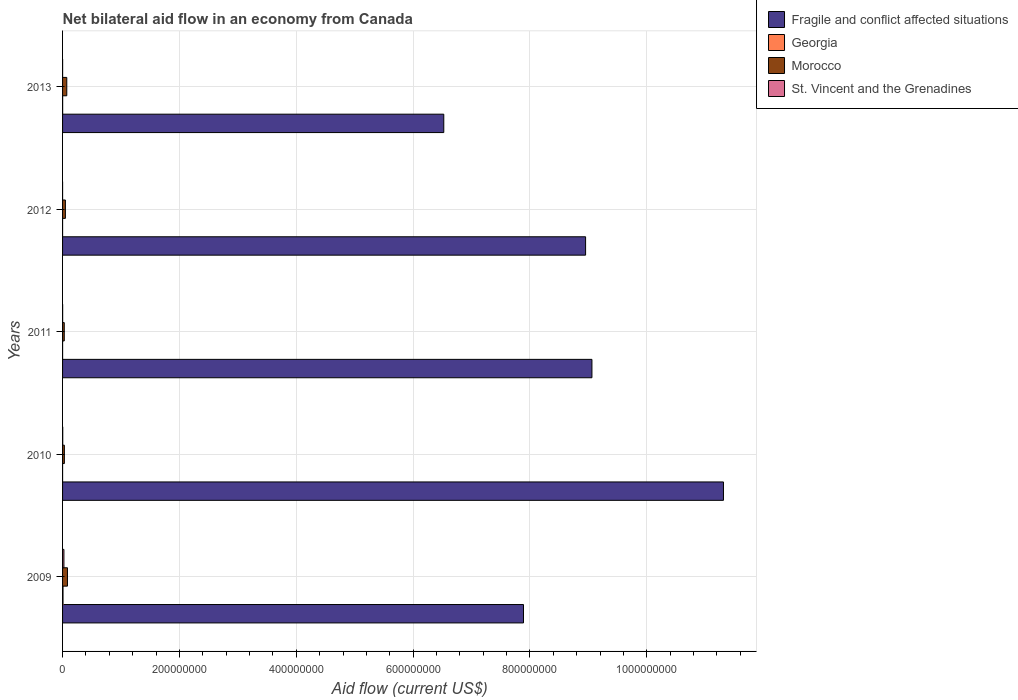How many groups of bars are there?
Provide a succinct answer. 5. Are the number of bars per tick equal to the number of legend labels?
Provide a short and direct response. Yes. Are the number of bars on each tick of the Y-axis equal?
Offer a terse response. Yes. How many bars are there on the 1st tick from the top?
Your answer should be very brief. 4. What is the net bilateral aid flow in Georgia in 2009?
Your response must be concise. 7.70e+05. Across all years, what is the maximum net bilateral aid flow in Fragile and conflict affected situations?
Offer a terse response. 1.13e+09. Across all years, what is the minimum net bilateral aid flow in Fragile and conflict affected situations?
Your answer should be very brief. 6.52e+08. In which year was the net bilateral aid flow in Georgia minimum?
Keep it short and to the point. 2012. What is the total net bilateral aid flow in Georgia in the graph?
Your answer should be very brief. 1.01e+06. What is the difference between the net bilateral aid flow in Morocco in 2011 and that in 2013?
Ensure brevity in your answer.  -4.30e+06. What is the difference between the net bilateral aid flow in Georgia in 2013 and the net bilateral aid flow in Morocco in 2012?
Your answer should be very brief. -4.71e+06. What is the average net bilateral aid flow in St. Vincent and the Grenadines per year?
Offer a very short reply. 5.70e+05. In the year 2011, what is the difference between the net bilateral aid flow in Georgia and net bilateral aid flow in Morocco?
Keep it short and to the point. -2.85e+06. In how many years, is the net bilateral aid flow in Morocco greater than 520000000 US$?
Provide a short and direct response. 0. What is the ratio of the net bilateral aid flow in St. Vincent and the Grenadines in 2009 to that in 2013?
Offer a very short reply. 33.29. Is the net bilateral aid flow in Fragile and conflict affected situations in 2010 less than that in 2012?
Your answer should be compact. No. What is the difference between the highest and the second highest net bilateral aid flow in Morocco?
Offer a very short reply. 1.17e+06. What is the difference between the highest and the lowest net bilateral aid flow in St. Vincent and the Grenadines?
Provide a succinct answer. 2.30e+06. What does the 2nd bar from the top in 2013 represents?
Offer a terse response. Morocco. What does the 1st bar from the bottom in 2009 represents?
Keep it short and to the point. Fragile and conflict affected situations. How many years are there in the graph?
Make the answer very short. 5. What is the difference between two consecutive major ticks on the X-axis?
Offer a terse response. 2.00e+08. Does the graph contain grids?
Your answer should be compact. Yes. Where does the legend appear in the graph?
Offer a terse response. Top right. How are the legend labels stacked?
Keep it short and to the point. Vertical. What is the title of the graph?
Ensure brevity in your answer.  Net bilateral aid flow in an economy from Canada. Does "Luxembourg" appear as one of the legend labels in the graph?
Ensure brevity in your answer.  No. What is the label or title of the Y-axis?
Your answer should be compact. Years. What is the Aid flow (current US$) of Fragile and conflict affected situations in 2009?
Ensure brevity in your answer.  7.89e+08. What is the Aid flow (current US$) in Georgia in 2009?
Offer a terse response. 7.70e+05. What is the Aid flow (current US$) in Morocco in 2009?
Keep it short and to the point. 8.38e+06. What is the Aid flow (current US$) in St. Vincent and the Grenadines in 2009?
Keep it short and to the point. 2.33e+06. What is the Aid flow (current US$) of Fragile and conflict affected situations in 2010?
Your answer should be very brief. 1.13e+09. What is the Aid flow (current US$) of Morocco in 2010?
Your answer should be compact. 3.10e+06. What is the Aid flow (current US$) in St. Vincent and the Grenadines in 2010?
Ensure brevity in your answer.  2.90e+05. What is the Aid flow (current US$) of Fragile and conflict affected situations in 2011?
Offer a very short reply. 9.06e+08. What is the Aid flow (current US$) of Georgia in 2011?
Your answer should be very brief. 6.00e+04. What is the Aid flow (current US$) of Morocco in 2011?
Provide a succinct answer. 2.91e+06. What is the Aid flow (current US$) of St. Vincent and the Grenadines in 2011?
Your answer should be very brief. 1.30e+05. What is the Aid flow (current US$) of Fragile and conflict affected situations in 2012?
Provide a short and direct response. 8.95e+08. What is the Aid flow (current US$) of Georgia in 2012?
Ensure brevity in your answer.  10000. What is the Aid flow (current US$) of Morocco in 2012?
Give a very brief answer. 4.85e+06. What is the Aid flow (current US$) in St. Vincent and the Grenadines in 2012?
Offer a terse response. 3.00e+04. What is the Aid flow (current US$) of Fragile and conflict affected situations in 2013?
Ensure brevity in your answer.  6.52e+08. What is the Aid flow (current US$) in Georgia in 2013?
Your answer should be very brief. 1.40e+05. What is the Aid flow (current US$) in Morocco in 2013?
Ensure brevity in your answer.  7.21e+06. What is the Aid flow (current US$) of St. Vincent and the Grenadines in 2013?
Give a very brief answer. 7.00e+04. Across all years, what is the maximum Aid flow (current US$) of Fragile and conflict affected situations?
Offer a terse response. 1.13e+09. Across all years, what is the maximum Aid flow (current US$) of Georgia?
Your response must be concise. 7.70e+05. Across all years, what is the maximum Aid flow (current US$) of Morocco?
Your response must be concise. 8.38e+06. Across all years, what is the maximum Aid flow (current US$) in St. Vincent and the Grenadines?
Make the answer very short. 2.33e+06. Across all years, what is the minimum Aid flow (current US$) in Fragile and conflict affected situations?
Your response must be concise. 6.52e+08. Across all years, what is the minimum Aid flow (current US$) of Georgia?
Give a very brief answer. 10000. Across all years, what is the minimum Aid flow (current US$) of Morocco?
Your response must be concise. 2.91e+06. What is the total Aid flow (current US$) of Fragile and conflict affected situations in the graph?
Give a very brief answer. 4.37e+09. What is the total Aid flow (current US$) in Georgia in the graph?
Make the answer very short. 1.01e+06. What is the total Aid flow (current US$) of Morocco in the graph?
Make the answer very short. 2.64e+07. What is the total Aid flow (current US$) of St. Vincent and the Grenadines in the graph?
Provide a succinct answer. 2.85e+06. What is the difference between the Aid flow (current US$) of Fragile and conflict affected situations in 2009 and that in 2010?
Your answer should be very brief. -3.42e+08. What is the difference between the Aid flow (current US$) of Georgia in 2009 and that in 2010?
Your answer should be very brief. 7.40e+05. What is the difference between the Aid flow (current US$) in Morocco in 2009 and that in 2010?
Offer a very short reply. 5.28e+06. What is the difference between the Aid flow (current US$) of St. Vincent and the Grenadines in 2009 and that in 2010?
Give a very brief answer. 2.04e+06. What is the difference between the Aid flow (current US$) in Fragile and conflict affected situations in 2009 and that in 2011?
Provide a short and direct response. -1.17e+08. What is the difference between the Aid flow (current US$) of Georgia in 2009 and that in 2011?
Keep it short and to the point. 7.10e+05. What is the difference between the Aid flow (current US$) in Morocco in 2009 and that in 2011?
Give a very brief answer. 5.47e+06. What is the difference between the Aid flow (current US$) in St. Vincent and the Grenadines in 2009 and that in 2011?
Your answer should be compact. 2.20e+06. What is the difference between the Aid flow (current US$) in Fragile and conflict affected situations in 2009 and that in 2012?
Your answer should be compact. -1.06e+08. What is the difference between the Aid flow (current US$) of Georgia in 2009 and that in 2012?
Offer a very short reply. 7.60e+05. What is the difference between the Aid flow (current US$) in Morocco in 2009 and that in 2012?
Give a very brief answer. 3.53e+06. What is the difference between the Aid flow (current US$) in St. Vincent and the Grenadines in 2009 and that in 2012?
Give a very brief answer. 2.30e+06. What is the difference between the Aid flow (current US$) of Fragile and conflict affected situations in 2009 and that in 2013?
Provide a succinct answer. 1.36e+08. What is the difference between the Aid flow (current US$) in Georgia in 2009 and that in 2013?
Provide a succinct answer. 6.30e+05. What is the difference between the Aid flow (current US$) of Morocco in 2009 and that in 2013?
Offer a very short reply. 1.17e+06. What is the difference between the Aid flow (current US$) in St. Vincent and the Grenadines in 2009 and that in 2013?
Keep it short and to the point. 2.26e+06. What is the difference between the Aid flow (current US$) in Fragile and conflict affected situations in 2010 and that in 2011?
Provide a succinct answer. 2.25e+08. What is the difference between the Aid flow (current US$) in St. Vincent and the Grenadines in 2010 and that in 2011?
Provide a succinct answer. 1.60e+05. What is the difference between the Aid flow (current US$) of Fragile and conflict affected situations in 2010 and that in 2012?
Ensure brevity in your answer.  2.36e+08. What is the difference between the Aid flow (current US$) in Morocco in 2010 and that in 2012?
Provide a succinct answer. -1.75e+06. What is the difference between the Aid flow (current US$) of St. Vincent and the Grenadines in 2010 and that in 2012?
Make the answer very short. 2.60e+05. What is the difference between the Aid flow (current US$) in Fragile and conflict affected situations in 2010 and that in 2013?
Ensure brevity in your answer.  4.79e+08. What is the difference between the Aid flow (current US$) in Georgia in 2010 and that in 2013?
Keep it short and to the point. -1.10e+05. What is the difference between the Aid flow (current US$) of Morocco in 2010 and that in 2013?
Your response must be concise. -4.11e+06. What is the difference between the Aid flow (current US$) of Fragile and conflict affected situations in 2011 and that in 2012?
Your answer should be very brief. 1.08e+07. What is the difference between the Aid flow (current US$) of Georgia in 2011 and that in 2012?
Make the answer very short. 5.00e+04. What is the difference between the Aid flow (current US$) in Morocco in 2011 and that in 2012?
Your response must be concise. -1.94e+06. What is the difference between the Aid flow (current US$) in St. Vincent and the Grenadines in 2011 and that in 2012?
Provide a succinct answer. 1.00e+05. What is the difference between the Aid flow (current US$) in Fragile and conflict affected situations in 2011 and that in 2013?
Provide a succinct answer. 2.54e+08. What is the difference between the Aid flow (current US$) in Morocco in 2011 and that in 2013?
Make the answer very short. -4.30e+06. What is the difference between the Aid flow (current US$) in St. Vincent and the Grenadines in 2011 and that in 2013?
Your answer should be compact. 6.00e+04. What is the difference between the Aid flow (current US$) of Fragile and conflict affected situations in 2012 and that in 2013?
Ensure brevity in your answer.  2.43e+08. What is the difference between the Aid flow (current US$) in Morocco in 2012 and that in 2013?
Offer a very short reply. -2.36e+06. What is the difference between the Aid flow (current US$) of St. Vincent and the Grenadines in 2012 and that in 2013?
Give a very brief answer. -4.00e+04. What is the difference between the Aid flow (current US$) of Fragile and conflict affected situations in 2009 and the Aid flow (current US$) of Georgia in 2010?
Your answer should be very brief. 7.89e+08. What is the difference between the Aid flow (current US$) in Fragile and conflict affected situations in 2009 and the Aid flow (current US$) in Morocco in 2010?
Your answer should be very brief. 7.86e+08. What is the difference between the Aid flow (current US$) of Fragile and conflict affected situations in 2009 and the Aid flow (current US$) of St. Vincent and the Grenadines in 2010?
Provide a succinct answer. 7.89e+08. What is the difference between the Aid flow (current US$) of Georgia in 2009 and the Aid flow (current US$) of Morocco in 2010?
Offer a terse response. -2.33e+06. What is the difference between the Aid flow (current US$) of Morocco in 2009 and the Aid flow (current US$) of St. Vincent and the Grenadines in 2010?
Ensure brevity in your answer.  8.09e+06. What is the difference between the Aid flow (current US$) in Fragile and conflict affected situations in 2009 and the Aid flow (current US$) in Georgia in 2011?
Provide a short and direct response. 7.89e+08. What is the difference between the Aid flow (current US$) in Fragile and conflict affected situations in 2009 and the Aid flow (current US$) in Morocco in 2011?
Make the answer very short. 7.86e+08. What is the difference between the Aid flow (current US$) of Fragile and conflict affected situations in 2009 and the Aid flow (current US$) of St. Vincent and the Grenadines in 2011?
Your response must be concise. 7.89e+08. What is the difference between the Aid flow (current US$) of Georgia in 2009 and the Aid flow (current US$) of Morocco in 2011?
Provide a succinct answer. -2.14e+06. What is the difference between the Aid flow (current US$) in Georgia in 2009 and the Aid flow (current US$) in St. Vincent and the Grenadines in 2011?
Your answer should be very brief. 6.40e+05. What is the difference between the Aid flow (current US$) in Morocco in 2009 and the Aid flow (current US$) in St. Vincent and the Grenadines in 2011?
Keep it short and to the point. 8.25e+06. What is the difference between the Aid flow (current US$) of Fragile and conflict affected situations in 2009 and the Aid flow (current US$) of Georgia in 2012?
Offer a very short reply. 7.89e+08. What is the difference between the Aid flow (current US$) in Fragile and conflict affected situations in 2009 and the Aid flow (current US$) in Morocco in 2012?
Your answer should be compact. 7.84e+08. What is the difference between the Aid flow (current US$) of Fragile and conflict affected situations in 2009 and the Aid flow (current US$) of St. Vincent and the Grenadines in 2012?
Your answer should be very brief. 7.89e+08. What is the difference between the Aid flow (current US$) of Georgia in 2009 and the Aid flow (current US$) of Morocco in 2012?
Make the answer very short. -4.08e+06. What is the difference between the Aid flow (current US$) in Georgia in 2009 and the Aid flow (current US$) in St. Vincent and the Grenadines in 2012?
Your response must be concise. 7.40e+05. What is the difference between the Aid flow (current US$) in Morocco in 2009 and the Aid flow (current US$) in St. Vincent and the Grenadines in 2012?
Your answer should be very brief. 8.35e+06. What is the difference between the Aid flow (current US$) in Fragile and conflict affected situations in 2009 and the Aid flow (current US$) in Georgia in 2013?
Ensure brevity in your answer.  7.89e+08. What is the difference between the Aid flow (current US$) of Fragile and conflict affected situations in 2009 and the Aid flow (current US$) of Morocco in 2013?
Provide a succinct answer. 7.82e+08. What is the difference between the Aid flow (current US$) of Fragile and conflict affected situations in 2009 and the Aid flow (current US$) of St. Vincent and the Grenadines in 2013?
Ensure brevity in your answer.  7.89e+08. What is the difference between the Aid flow (current US$) in Georgia in 2009 and the Aid flow (current US$) in Morocco in 2013?
Offer a very short reply. -6.44e+06. What is the difference between the Aid flow (current US$) of Georgia in 2009 and the Aid flow (current US$) of St. Vincent and the Grenadines in 2013?
Offer a very short reply. 7.00e+05. What is the difference between the Aid flow (current US$) of Morocco in 2009 and the Aid flow (current US$) of St. Vincent and the Grenadines in 2013?
Provide a short and direct response. 8.31e+06. What is the difference between the Aid flow (current US$) of Fragile and conflict affected situations in 2010 and the Aid flow (current US$) of Georgia in 2011?
Offer a very short reply. 1.13e+09. What is the difference between the Aid flow (current US$) of Fragile and conflict affected situations in 2010 and the Aid flow (current US$) of Morocco in 2011?
Provide a short and direct response. 1.13e+09. What is the difference between the Aid flow (current US$) of Fragile and conflict affected situations in 2010 and the Aid flow (current US$) of St. Vincent and the Grenadines in 2011?
Your answer should be compact. 1.13e+09. What is the difference between the Aid flow (current US$) of Georgia in 2010 and the Aid flow (current US$) of Morocco in 2011?
Offer a very short reply. -2.88e+06. What is the difference between the Aid flow (current US$) in Morocco in 2010 and the Aid flow (current US$) in St. Vincent and the Grenadines in 2011?
Give a very brief answer. 2.97e+06. What is the difference between the Aid flow (current US$) of Fragile and conflict affected situations in 2010 and the Aid flow (current US$) of Georgia in 2012?
Offer a terse response. 1.13e+09. What is the difference between the Aid flow (current US$) in Fragile and conflict affected situations in 2010 and the Aid flow (current US$) in Morocco in 2012?
Make the answer very short. 1.13e+09. What is the difference between the Aid flow (current US$) in Fragile and conflict affected situations in 2010 and the Aid flow (current US$) in St. Vincent and the Grenadines in 2012?
Ensure brevity in your answer.  1.13e+09. What is the difference between the Aid flow (current US$) of Georgia in 2010 and the Aid flow (current US$) of Morocco in 2012?
Ensure brevity in your answer.  -4.82e+06. What is the difference between the Aid flow (current US$) in Georgia in 2010 and the Aid flow (current US$) in St. Vincent and the Grenadines in 2012?
Give a very brief answer. 0. What is the difference between the Aid flow (current US$) in Morocco in 2010 and the Aid flow (current US$) in St. Vincent and the Grenadines in 2012?
Provide a short and direct response. 3.07e+06. What is the difference between the Aid flow (current US$) in Fragile and conflict affected situations in 2010 and the Aid flow (current US$) in Georgia in 2013?
Provide a short and direct response. 1.13e+09. What is the difference between the Aid flow (current US$) in Fragile and conflict affected situations in 2010 and the Aid flow (current US$) in Morocco in 2013?
Offer a very short reply. 1.12e+09. What is the difference between the Aid flow (current US$) of Fragile and conflict affected situations in 2010 and the Aid flow (current US$) of St. Vincent and the Grenadines in 2013?
Your answer should be very brief. 1.13e+09. What is the difference between the Aid flow (current US$) in Georgia in 2010 and the Aid flow (current US$) in Morocco in 2013?
Provide a short and direct response. -7.18e+06. What is the difference between the Aid flow (current US$) of Morocco in 2010 and the Aid flow (current US$) of St. Vincent and the Grenadines in 2013?
Give a very brief answer. 3.03e+06. What is the difference between the Aid flow (current US$) of Fragile and conflict affected situations in 2011 and the Aid flow (current US$) of Georgia in 2012?
Keep it short and to the point. 9.06e+08. What is the difference between the Aid flow (current US$) in Fragile and conflict affected situations in 2011 and the Aid flow (current US$) in Morocco in 2012?
Give a very brief answer. 9.01e+08. What is the difference between the Aid flow (current US$) in Fragile and conflict affected situations in 2011 and the Aid flow (current US$) in St. Vincent and the Grenadines in 2012?
Your answer should be very brief. 9.06e+08. What is the difference between the Aid flow (current US$) in Georgia in 2011 and the Aid flow (current US$) in Morocco in 2012?
Keep it short and to the point. -4.79e+06. What is the difference between the Aid flow (current US$) of Georgia in 2011 and the Aid flow (current US$) of St. Vincent and the Grenadines in 2012?
Ensure brevity in your answer.  3.00e+04. What is the difference between the Aid flow (current US$) in Morocco in 2011 and the Aid flow (current US$) in St. Vincent and the Grenadines in 2012?
Offer a very short reply. 2.88e+06. What is the difference between the Aid flow (current US$) in Fragile and conflict affected situations in 2011 and the Aid flow (current US$) in Georgia in 2013?
Your response must be concise. 9.06e+08. What is the difference between the Aid flow (current US$) in Fragile and conflict affected situations in 2011 and the Aid flow (current US$) in Morocco in 2013?
Provide a succinct answer. 8.99e+08. What is the difference between the Aid flow (current US$) of Fragile and conflict affected situations in 2011 and the Aid flow (current US$) of St. Vincent and the Grenadines in 2013?
Ensure brevity in your answer.  9.06e+08. What is the difference between the Aid flow (current US$) of Georgia in 2011 and the Aid flow (current US$) of Morocco in 2013?
Make the answer very short. -7.15e+06. What is the difference between the Aid flow (current US$) of Morocco in 2011 and the Aid flow (current US$) of St. Vincent and the Grenadines in 2013?
Provide a short and direct response. 2.84e+06. What is the difference between the Aid flow (current US$) of Fragile and conflict affected situations in 2012 and the Aid flow (current US$) of Georgia in 2013?
Make the answer very short. 8.95e+08. What is the difference between the Aid flow (current US$) of Fragile and conflict affected situations in 2012 and the Aid flow (current US$) of Morocco in 2013?
Keep it short and to the point. 8.88e+08. What is the difference between the Aid flow (current US$) in Fragile and conflict affected situations in 2012 and the Aid flow (current US$) in St. Vincent and the Grenadines in 2013?
Ensure brevity in your answer.  8.95e+08. What is the difference between the Aid flow (current US$) in Georgia in 2012 and the Aid flow (current US$) in Morocco in 2013?
Keep it short and to the point. -7.20e+06. What is the difference between the Aid flow (current US$) of Georgia in 2012 and the Aid flow (current US$) of St. Vincent and the Grenadines in 2013?
Keep it short and to the point. -6.00e+04. What is the difference between the Aid flow (current US$) of Morocco in 2012 and the Aid flow (current US$) of St. Vincent and the Grenadines in 2013?
Your answer should be compact. 4.78e+06. What is the average Aid flow (current US$) of Fragile and conflict affected situations per year?
Offer a terse response. 8.75e+08. What is the average Aid flow (current US$) in Georgia per year?
Offer a terse response. 2.02e+05. What is the average Aid flow (current US$) in Morocco per year?
Give a very brief answer. 5.29e+06. What is the average Aid flow (current US$) in St. Vincent and the Grenadines per year?
Provide a succinct answer. 5.70e+05. In the year 2009, what is the difference between the Aid flow (current US$) in Fragile and conflict affected situations and Aid flow (current US$) in Georgia?
Offer a terse response. 7.88e+08. In the year 2009, what is the difference between the Aid flow (current US$) of Fragile and conflict affected situations and Aid flow (current US$) of Morocco?
Your response must be concise. 7.81e+08. In the year 2009, what is the difference between the Aid flow (current US$) of Fragile and conflict affected situations and Aid flow (current US$) of St. Vincent and the Grenadines?
Provide a short and direct response. 7.87e+08. In the year 2009, what is the difference between the Aid flow (current US$) of Georgia and Aid flow (current US$) of Morocco?
Offer a very short reply. -7.61e+06. In the year 2009, what is the difference between the Aid flow (current US$) in Georgia and Aid flow (current US$) in St. Vincent and the Grenadines?
Your answer should be very brief. -1.56e+06. In the year 2009, what is the difference between the Aid flow (current US$) in Morocco and Aid flow (current US$) in St. Vincent and the Grenadines?
Offer a terse response. 6.05e+06. In the year 2010, what is the difference between the Aid flow (current US$) of Fragile and conflict affected situations and Aid flow (current US$) of Georgia?
Give a very brief answer. 1.13e+09. In the year 2010, what is the difference between the Aid flow (current US$) in Fragile and conflict affected situations and Aid flow (current US$) in Morocco?
Ensure brevity in your answer.  1.13e+09. In the year 2010, what is the difference between the Aid flow (current US$) of Fragile and conflict affected situations and Aid flow (current US$) of St. Vincent and the Grenadines?
Make the answer very short. 1.13e+09. In the year 2010, what is the difference between the Aid flow (current US$) of Georgia and Aid flow (current US$) of Morocco?
Make the answer very short. -3.07e+06. In the year 2010, what is the difference between the Aid flow (current US$) in Morocco and Aid flow (current US$) in St. Vincent and the Grenadines?
Offer a terse response. 2.81e+06. In the year 2011, what is the difference between the Aid flow (current US$) of Fragile and conflict affected situations and Aid flow (current US$) of Georgia?
Keep it short and to the point. 9.06e+08. In the year 2011, what is the difference between the Aid flow (current US$) in Fragile and conflict affected situations and Aid flow (current US$) in Morocco?
Your answer should be compact. 9.03e+08. In the year 2011, what is the difference between the Aid flow (current US$) of Fragile and conflict affected situations and Aid flow (current US$) of St. Vincent and the Grenadines?
Make the answer very short. 9.06e+08. In the year 2011, what is the difference between the Aid flow (current US$) of Georgia and Aid flow (current US$) of Morocco?
Make the answer very short. -2.85e+06. In the year 2011, what is the difference between the Aid flow (current US$) of Georgia and Aid flow (current US$) of St. Vincent and the Grenadines?
Offer a very short reply. -7.00e+04. In the year 2011, what is the difference between the Aid flow (current US$) of Morocco and Aid flow (current US$) of St. Vincent and the Grenadines?
Your answer should be compact. 2.78e+06. In the year 2012, what is the difference between the Aid flow (current US$) of Fragile and conflict affected situations and Aid flow (current US$) of Georgia?
Offer a very short reply. 8.95e+08. In the year 2012, what is the difference between the Aid flow (current US$) in Fragile and conflict affected situations and Aid flow (current US$) in Morocco?
Ensure brevity in your answer.  8.90e+08. In the year 2012, what is the difference between the Aid flow (current US$) of Fragile and conflict affected situations and Aid flow (current US$) of St. Vincent and the Grenadines?
Ensure brevity in your answer.  8.95e+08. In the year 2012, what is the difference between the Aid flow (current US$) of Georgia and Aid flow (current US$) of Morocco?
Give a very brief answer. -4.84e+06. In the year 2012, what is the difference between the Aid flow (current US$) of Georgia and Aid flow (current US$) of St. Vincent and the Grenadines?
Your response must be concise. -2.00e+04. In the year 2012, what is the difference between the Aid flow (current US$) in Morocco and Aid flow (current US$) in St. Vincent and the Grenadines?
Offer a terse response. 4.82e+06. In the year 2013, what is the difference between the Aid flow (current US$) in Fragile and conflict affected situations and Aid flow (current US$) in Georgia?
Give a very brief answer. 6.52e+08. In the year 2013, what is the difference between the Aid flow (current US$) in Fragile and conflict affected situations and Aid flow (current US$) in Morocco?
Offer a terse response. 6.45e+08. In the year 2013, what is the difference between the Aid flow (current US$) in Fragile and conflict affected situations and Aid flow (current US$) in St. Vincent and the Grenadines?
Your answer should be very brief. 6.52e+08. In the year 2013, what is the difference between the Aid flow (current US$) in Georgia and Aid flow (current US$) in Morocco?
Your answer should be very brief. -7.07e+06. In the year 2013, what is the difference between the Aid flow (current US$) in Georgia and Aid flow (current US$) in St. Vincent and the Grenadines?
Offer a terse response. 7.00e+04. In the year 2013, what is the difference between the Aid flow (current US$) in Morocco and Aid flow (current US$) in St. Vincent and the Grenadines?
Give a very brief answer. 7.14e+06. What is the ratio of the Aid flow (current US$) in Fragile and conflict affected situations in 2009 to that in 2010?
Offer a terse response. 0.7. What is the ratio of the Aid flow (current US$) in Georgia in 2009 to that in 2010?
Your response must be concise. 25.67. What is the ratio of the Aid flow (current US$) in Morocco in 2009 to that in 2010?
Keep it short and to the point. 2.7. What is the ratio of the Aid flow (current US$) of St. Vincent and the Grenadines in 2009 to that in 2010?
Make the answer very short. 8.03. What is the ratio of the Aid flow (current US$) of Fragile and conflict affected situations in 2009 to that in 2011?
Your answer should be compact. 0.87. What is the ratio of the Aid flow (current US$) of Georgia in 2009 to that in 2011?
Your answer should be very brief. 12.83. What is the ratio of the Aid flow (current US$) of Morocco in 2009 to that in 2011?
Offer a terse response. 2.88. What is the ratio of the Aid flow (current US$) of St. Vincent and the Grenadines in 2009 to that in 2011?
Make the answer very short. 17.92. What is the ratio of the Aid flow (current US$) in Fragile and conflict affected situations in 2009 to that in 2012?
Your answer should be compact. 0.88. What is the ratio of the Aid flow (current US$) in Georgia in 2009 to that in 2012?
Provide a succinct answer. 77. What is the ratio of the Aid flow (current US$) in Morocco in 2009 to that in 2012?
Provide a succinct answer. 1.73. What is the ratio of the Aid flow (current US$) of St. Vincent and the Grenadines in 2009 to that in 2012?
Make the answer very short. 77.67. What is the ratio of the Aid flow (current US$) of Fragile and conflict affected situations in 2009 to that in 2013?
Your response must be concise. 1.21. What is the ratio of the Aid flow (current US$) of Georgia in 2009 to that in 2013?
Make the answer very short. 5.5. What is the ratio of the Aid flow (current US$) in Morocco in 2009 to that in 2013?
Your answer should be compact. 1.16. What is the ratio of the Aid flow (current US$) of St. Vincent and the Grenadines in 2009 to that in 2013?
Provide a succinct answer. 33.29. What is the ratio of the Aid flow (current US$) in Fragile and conflict affected situations in 2010 to that in 2011?
Ensure brevity in your answer.  1.25. What is the ratio of the Aid flow (current US$) in Georgia in 2010 to that in 2011?
Keep it short and to the point. 0.5. What is the ratio of the Aid flow (current US$) of Morocco in 2010 to that in 2011?
Give a very brief answer. 1.07. What is the ratio of the Aid flow (current US$) of St. Vincent and the Grenadines in 2010 to that in 2011?
Your answer should be very brief. 2.23. What is the ratio of the Aid flow (current US$) in Fragile and conflict affected situations in 2010 to that in 2012?
Offer a very short reply. 1.26. What is the ratio of the Aid flow (current US$) of Morocco in 2010 to that in 2012?
Ensure brevity in your answer.  0.64. What is the ratio of the Aid flow (current US$) in St. Vincent and the Grenadines in 2010 to that in 2012?
Keep it short and to the point. 9.67. What is the ratio of the Aid flow (current US$) of Fragile and conflict affected situations in 2010 to that in 2013?
Offer a terse response. 1.73. What is the ratio of the Aid flow (current US$) of Georgia in 2010 to that in 2013?
Provide a succinct answer. 0.21. What is the ratio of the Aid flow (current US$) in Morocco in 2010 to that in 2013?
Give a very brief answer. 0.43. What is the ratio of the Aid flow (current US$) of St. Vincent and the Grenadines in 2010 to that in 2013?
Your answer should be compact. 4.14. What is the ratio of the Aid flow (current US$) in Fragile and conflict affected situations in 2011 to that in 2012?
Provide a succinct answer. 1.01. What is the ratio of the Aid flow (current US$) in Morocco in 2011 to that in 2012?
Ensure brevity in your answer.  0.6. What is the ratio of the Aid flow (current US$) in St. Vincent and the Grenadines in 2011 to that in 2012?
Provide a short and direct response. 4.33. What is the ratio of the Aid flow (current US$) of Fragile and conflict affected situations in 2011 to that in 2013?
Make the answer very short. 1.39. What is the ratio of the Aid flow (current US$) in Georgia in 2011 to that in 2013?
Provide a succinct answer. 0.43. What is the ratio of the Aid flow (current US$) of Morocco in 2011 to that in 2013?
Provide a short and direct response. 0.4. What is the ratio of the Aid flow (current US$) of St. Vincent and the Grenadines in 2011 to that in 2013?
Give a very brief answer. 1.86. What is the ratio of the Aid flow (current US$) of Fragile and conflict affected situations in 2012 to that in 2013?
Offer a terse response. 1.37. What is the ratio of the Aid flow (current US$) in Georgia in 2012 to that in 2013?
Offer a terse response. 0.07. What is the ratio of the Aid flow (current US$) in Morocco in 2012 to that in 2013?
Your response must be concise. 0.67. What is the ratio of the Aid flow (current US$) in St. Vincent and the Grenadines in 2012 to that in 2013?
Your answer should be very brief. 0.43. What is the difference between the highest and the second highest Aid flow (current US$) of Fragile and conflict affected situations?
Offer a terse response. 2.25e+08. What is the difference between the highest and the second highest Aid flow (current US$) in Georgia?
Make the answer very short. 6.30e+05. What is the difference between the highest and the second highest Aid flow (current US$) in Morocco?
Offer a very short reply. 1.17e+06. What is the difference between the highest and the second highest Aid flow (current US$) in St. Vincent and the Grenadines?
Offer a very short reply. 2.04e+06. What is the difference between the highest and the lowest Aid flow (current US$) in Fragile and conflict affected situations?
Provide a short and direct response. 4.79e+08. What is the difference between the highest and the lowest Aid flow (current US$) of Georgia?
Offer a terse response. 7.60e+05. What is the difference between the highest and the lowest Aid flow (current US$) in Morocco?
Your answer should be compact. 5.47e+06. What is the difference between the highest and the lowest Aid flow (current US$) in St. Vincent and the Grenadines?
Your answer should be very brief. 2.30e+06. 